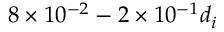<formula> <loc_0><loc_0><loc_500><loc_500>8 \times 1 0 ^ { - 2 } - 2 \times 1 0 ^ { - 1 } d _ { i }</formula> 